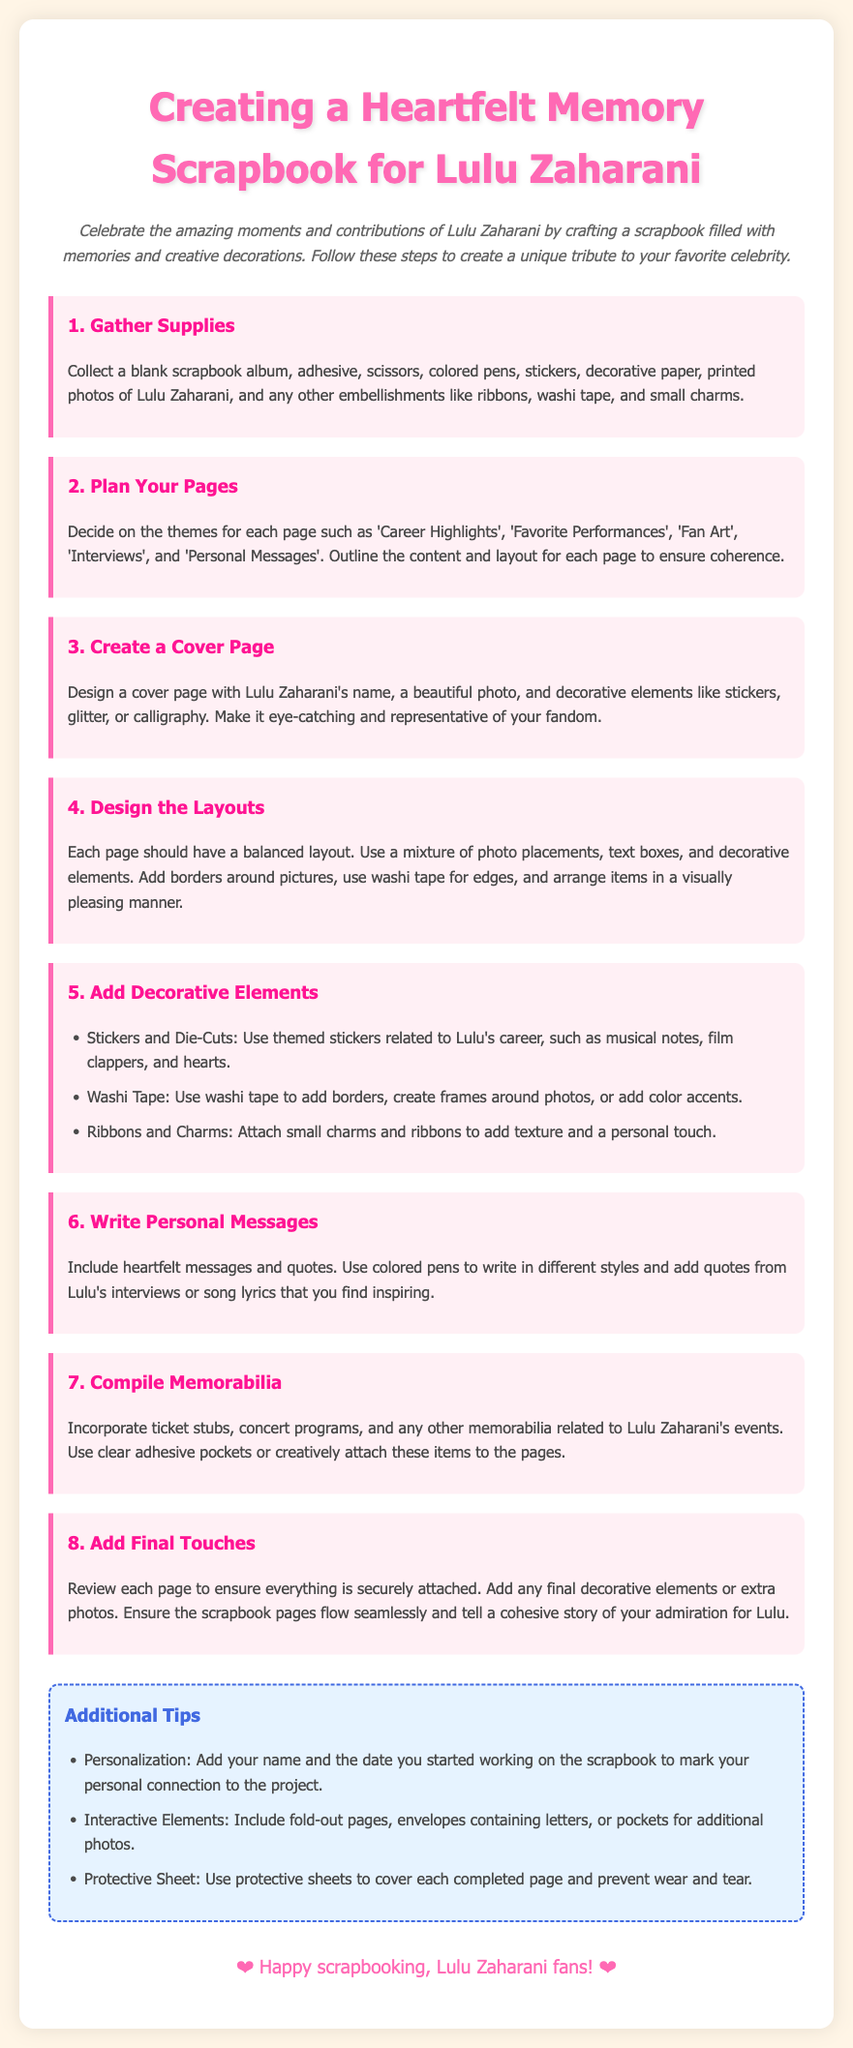What is the title of the scrapbook instructions? The title is found in the header of the document, which states the purpose of the instructions.
Answer: Creating a Heartfelt Memory Scrapbook for Lulu Zaharani How many steps are there in the instructions? The document lists a total of eight distinct steps for creating the scrapbook.
Answer: 8 What should be included in step 1? Step 1 specifies the necessary materials needed for starting the scrapbook.
Answer: Gather Supplies What is a suggested theme for the pages? The document provides examples of themes that can be used for the scrapbook pages.
Answer: Career Highlights What decorative element is suggested for the cover page? The instructions mention specific types of decorations suitable for the scrapbook cover.
Answer: Stickers What is one example of memorabilia to be added? The document lists various items that can serve as keepsakes in the scrapbook.
Answer: Ticket stubs What color is used for the background of the body text? The background color is described in the styling section of the document for visual presentation.
Answer: #FFF5E6 What type of messages are encouraged to be included in step 6? Step 6 emphasizes expressing personal thoughts and sentiments related to Lulu Zaharani.
Answer: Personal Messages 